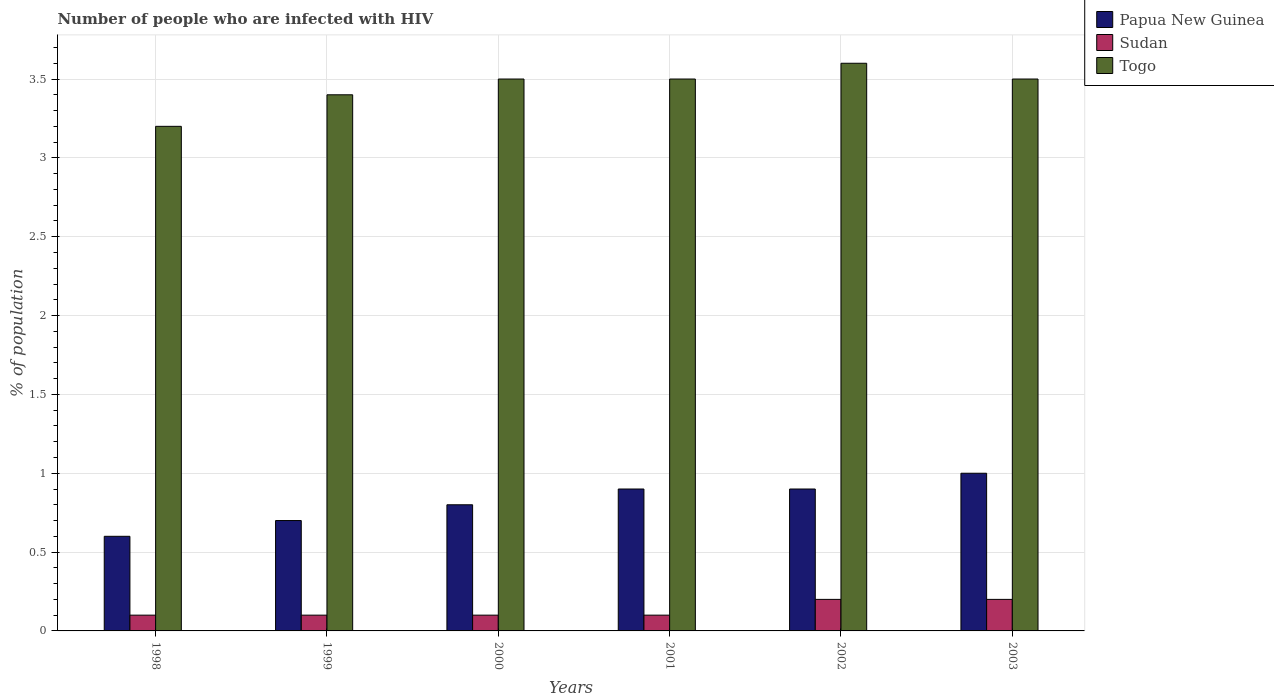How many different coloured bars are there?
Provide a short and direct response. 3. How many groups of bars are there?
Your answer should be compact. 6. Are the number of bars per tick equal to the number of legend labels?
Offer a terse response. Yes. Are the number of bars on each tick of the X-axis equal?
Offer a terse response. Yes. How many bars are there on the 5th tick from the right?
Offer a terse response. 3. In how many cases, is the number of bars for a given year not equal to the number of legend labels?
Provide a short and direct response. 0. What is the percentage of HIV infected population in in Togo in 2001?
Your response must be concise. 3.5. In which year was the percentage of HIV infected population in in Sudan minimum?
Offer a very short reply. 1998. What is the total percentage of HIV infected population in in Sudan in the graph?
Make the answer very short. 0.8. What is the difference between the percentage of HIV infected population in in Papua New Guinea in 1999 and that in 2000?
Your answer should be very brief. -0.1. What is the average percentage of HIV infected population in in Togo per year?
Your response must be concise. 3.45. What is the ratio of the percentage of HIV infected population in in Papua New Guinea in 2002 to that in 2003?
Your answer should be compact. 0.9. Is the difference between the percentage of HIV infected population in in Papua New Guinea in 2000 and 2001 greater than the difference between the percentage of HIV infected population in in Sudan in 2000 and 2001?
Keep it short and to the point. No. What is the difference between the highest and the second highest percentage of HIV infected population in in Papua New Guinea?
Make the answer very short. 0.1. What is the difference between the highest and the lowest percentage of HIV infected population in in Togo?
Make the answer very short. 0.4. What does the 2nd bar from the left in 2003 represents?
Your answer should be very brief. Sudan. What does the 2nd bar from the right in 2002 represents?
Ensure brevity in your answer.  Sudan. Is it the case that in every year, the sum of the percentage of HIV infected population in in Sudan and percentage of HIV infected population in in Papua New Guinea is greater than the percentage of HIV infected population in in Togo?
Ensure brevity in your answer.  No. How many bars are there?
Your answer should be compact. 18. Are all the bars in the graph horizontal?
Provide a short and direct response. No. Are the values on the major ticks of Y-axis written in scientific E-notation?
Offer a very short reply. No. Where does the legend appear in the graph?
Provide a short and direct response. Top right. How many legend labels are there?
Provide a succinct answer. 3. What is the title of the graph?
Keep it short and to the point. Number of people who are infected with HIV. What is the label or title of the Y-axis?
Ensure brevity in your answer.  % of population. What is the % of population of Papua New Guinea in 1998?
Provide a succinct answer. 0.6. What is the % of population in Togo in 1998?
Provide a succinct answer. 3.2. What is the % of population of Togo in 1999?
Your answer should be compact. 3.4. What is the % of population in Papua New Guinea in 2000?
Offer a terse response. 0.8. What is the % of population of Papua New Guinea in 2001?
Make the answer very short. 0.9. What is the % of population of Sudan in 2001?
Ensure brevity in your answer.  0.1. What is the % of population in Papua New Guinea in 2002?
Keep it short and to the point. 0.9. What is the % of population of Togo in 2002?
Your answer should be compact. 3.6. What is the % of population of Papua New Guinea in 2003?
Provide a short and direct response. 1. Across all years, what is the maximum % of population in Papua New Guinea?
Give a very brief answer. 1. Across all years, what is the maximum % of population in Sudan?
Provide a short and direct response. 0.2. Across all years, what is the minimum % of population in Papua New Guinea?
Your answer should be compact. 0.6. Across all years, what is the minimum % of population in Sudan?
Your response must be concise. 0.1. What is the total % of population in Papua New Guinea in the graph?
Your response must be concise. 4.9. What is the total % of population in Togo in the graph?
Your answer should be compact. 20.7. What is the difference between the % of population of Papua New Guinea in 1998 and that in 1999?
Provide a short and direct response. -0.1. What is the difference between the % of population of Sudan in 1998 and that in 1999?
Make the answer very short. 0. What is the difference between the % of population in Papua New Guinea in 1998 and that in 2000?
Provide a succinct answer. -0.2. What is the difference between the % of population of Sudan in 1998 and that in 2000?
Provide a short and direct response. 0. What is the difference between the % of population of Togo in 1998 and that in 2001?
Offer a terse response. -0.3. What is the difference between the % of population in Togo in 1998 and that in 2002?
Your response must be concise. -0.4. What is the difference between the % of population of Sudan in 1998 and that in 2003?
Provide a short and direct response. -0.1. What is the difference between the % of population in Sudan in 1999 and that in 2000?
Ensure brevity in your answer.  0. What is the difference between the % of population in Togo in 1999 and that in 2000?
Provide a succinct answer. -0.1. What is the difference between the % of population in Papua New Guinea in 1999 and that in 2003?
Your answer should be very brief. -0.3. What is the difference between the % of population of Togo in 1999 and that in 2003?
Offer a terse response. -0.1. What is the difference between the % of population of Papua New Guinea in 2000 and that in 2002?
Your answer should be very brief. -0.1. What is the difference between the % of population of Sudan in 2000 and that in 2002?
Give a very brief answer. -0.1. What is the difference between the % of population in Papua New Guinea in 2000 and that in 2003?
Offer a very short reply. -0.2. What is the difference between the % of population of Sudan in 2000 and that in 2003?
Provide a succinct answer. -0.1. What is the difference between the % of population in Togo in 2000 and that in 2003?
Offer a terse response. 0. What is the difference between the % of population in Papua New Guinea in 2001 and that in 2002?
Offer a terse response. 0. What is the difference between the % of population of Papua New Guinea in 2001 and that in 2003?
Give a very brief answer. -0.1. What is the difference between the % of population in Sudan in 2001 and that in 2003?
Ensure brevity in your answer.  -0.1. What is the difference between the % of population of Papua New Guinea in 2002 and that in 2003?
Keep it short and to the point. -0.1. What is the difference between the % of population in Sudan in 2002 and that in 2003?
Give a very brief answer. 0. What is the difference between the % of population in Papua New Guinea in 1998 and the % of population in Togo in 1999?
Offer a terse response. -2.8. What is the difference between the % of population of Sudan in 1998 and the % of population of Togo in 1999?
Offer a very short reply. -3.3. What is the difference between the % of population in Papua New Guinea in 1998 and the % of population in Sudan in 2000?
Your response must be concise. 0.5. What is the difference between the % of population of Sudan in 1998 and the % of population of Togo in 2000?
Ensure brevity in your answer.  -3.4. What is the difference between the % of population of Papua New Guinea in 1998 and the % of population of Togo in 2001?
Keep it short and to the point. -2.9. What is the difference between the % of population in Sudan in 1998 and the % of population in Togo in 2001?
Ensure brevity in your answer.  -3.4. What is the difference between the % of population of Papua New Guinea in 1998 and the % of population of Sudan in 2002?
Provide a succinct answer. 0.4. What is the difference between the % of population of Sudan in 1998 and the % of population of Togo in 2002?
Your answer should be compact. -3.5. What is the difference between the % of population of Papua New Guinea in 1998 and the % of population of Sudan in 2003?
Provide a short and direct response. 0.4. What is the difference between the % of population in Papua New Guinea in 1998 and the % of population in Togo in 2003?
Offer a very short reply. -2.9. What is the difference between the % of population of Papua New Guinea in 1999 and the % of population of Sudan in 2000?
Give a very brief answer. 0.6. What is the difference between the % of population of Papua New Guinea in 1999 and the % of population of Togo in 2000?
Offer a terse response. -2.8. What is the difference between the % of population in Sudan in 1999 and the % of population in Togo in 2001?
Your answer should be very brief. -3.4. What is the difference between the % of population of Papua New Guinea in 1999 and the % of population of Togo in 2002?
Offer a very short reply. -2.9. What is the difference between the % of population in Sudan in 1999 and the % of population in Togo in 2002?
Offer a terse response. -3.5. What is the difference between the % of population of Papua New Guinea in 1999 and the % of population of Togo in 2003?
Offer a very short reply. -2.8. What is the difference between the % of population of Sudan in 1999 and the % of population of Togo in 2003?
Keep it short and to the point. -3.4. What is the difference between the % of population in Papua New Guinea in 2000 and the % of population in Sudan in 2002?
Offer a terse response. 0.6. What is the difference between the % of population of Sudan in 2000 and the % of population of Togo in 2002?
Offer a terse response. -3.5. What is the difference between the % of population of Papua New Guinea in 2000 and the % of population of Togo in 2003?
Provide a succinct answer. -2.7. What is the difference between the % of population in Papua New Guinea in 2002 and the % of population in Sudan in 2003?
Provide a succinct answer. 0.7. What is the difference between the % of population in Papua New Guinea in 2002 and the % of population in Togo in 2003?
Give a very brief answer. -2.6. What is the difference between the % of population of Sudan in 2002 and the % of population of Togo in 2003?
Make the answer very short. -3.3. What is the average % of population of Papua New Guinea per year?
Offer a terse response. 0.82. What is the average % of population in Sudan per year?
Offer a terse response. 0.13. What is the average % of population in Togo per year?
Offer a terse response. 3.45. In the year 1998, what is the difference between the % of population in Papua New Guinea and % of population in Togo?
Provide a succinct answer. -2.6. In the year 1998, what is the difference between the % of population in Sudan and % of population in Togo?
Offer a terse response. -3.1. In the year 1999, what is the difference between the % of population of Sudan and % of population of Togo?
Your answer should be compact. -3.3. In the year 2000, what is the difference between the % of population in Papua New Guinea and % of population in Togo?
Offer a very short reply. -2.7. In the year 2001, what is the difference between the % of population of Papua New Guinea and % of population of Togo?
Provide a short and direct response. -2.6. In the year 2002, what is the difference between the % of population of Papua New Guinea and % of population of Sudan?
Your response must be concise. 0.7. In the year 2002, what is the difference between the % of population of Sudan and % of population of Togo?
Your answer should be compact. -3.4. In the year 2003, what is the difference between the % of population of Papua New Guinea and % of population of Sudan?
Ensure brevity in your answer.  0.8. What is the ratio of the % of population in Sudan in 1998 to that in 1999?
Your answer should be very brief. 1. What is the ratio of the % of population in Sudan in 1998 to that in 2000?
Ensure brevity in your answer.  1. What is the ratio of the % of population of Togo in 1998 to that in 2000?
Make the answer very short. 0.91. What is the ratio of the % of population of Papua New Guinea in 1998 to that in 2001?
Provide a succinct answer. 0.67. What is the ratio of the % of population in Togo in 1998 to that in 2001?
Offer a very short reply. 0.91. What is the ratio of the % of population of Papua New Guinea in 1998 to that in 2003?
Offer a terse response. 0.6. What is the ratio of the % of population of Togo in 1998 to that in 2003?
Make the answer very short. 0.91. What is the ratio of the % of population of Papua New Guinea in 1999 to that in 2000?
Provide a short and direct response. 0.88. What is the ratio of the % of population in Togo in 1999 to that in 2000?
Give a very brief answer. 0.97. What is the ratio of the % of population in Papua New Guinea in 1999 to that in 2001?
Give a very brief answer. 0.78. What is the ratio of the % of population in Sudan in 1999 to that in 2001?
Keep it short and to the point. 1. What is the ratio of the % of population in Togo in 1999 to that in 2001?
Give a very brief answer. 0.97. What is the ratio of the % of population in Togo in 1999 to that in 2002?
Your answer should be very brief. 0.94. What is the ratio of the % of population in Sudan in 1999 to that in 2003?
Your answer should be compact. 0.5. What is the ratio of the % of population of Togo in 1999 to that in 2003?
Provide a succinct answer. 0.97. What is the ratio of the % of population in Sudan in 2000 to that in 2001?
Make the answer very short. 1. What is the ratio of the % of population in Togo in 2000 to that in 2001?
Make the answer very short. 1. What is the ratio of the % of population of Papua New Guinea in 2000 to that in 2002?
Your answer should be compact. 0.89. What is the ratio of the % of population of Sudan in 2000 to that in 2002?
Your answer should be very brief. 0.5. What is the ratio of the % of population of Togo in 2000 to that in 2002?
Your response must be concise. 0.97. What is the ratio of the % of population in Papua New Guinea in 2000 to that in 2003?
Provide a short and direct response. 0.8. What is the ratio of the % of population in Togo in 2000 to that in 2003?
Your answer should be very brief. 1. What is the ratio of the % of population in Togo in 2001 to that in 2002?
Provide a short and direct response. 0.97. What is the ratio of the % of population in Togo in 2002 to that in 2003?
Keep it short and to the point. 1.03. What is the difference between the highest and the second highest % of population of Togo?
Keep it short and to the point. 0.1. What is the difference between the highest and the lowest % of population in Sudan?
Provide a succinct answer. 0.1. What is the difference between the highest and the lowest % of population of Togo?
Ensure brevity in your answer.  0.4. 